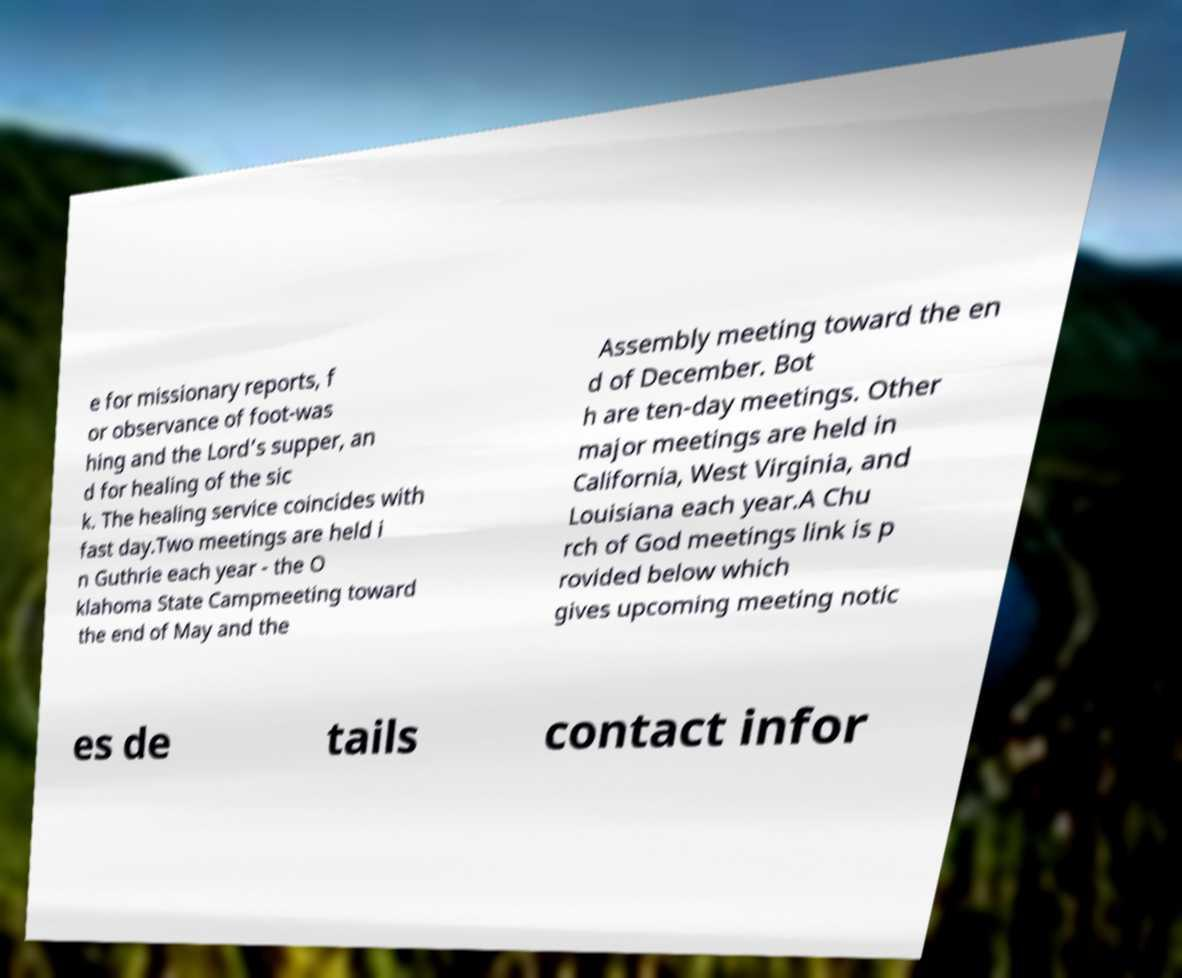For documentation purposes, I need the text within this image transcribed. Could you provide that? e for missionary reports, f or observance of foot-was hing and the Lord’s supper, an d for healing of the sic k. The healing service coincides with fast day.Two meetings are held i n Guthrie each year - the O klahoma State Campmeeting toward the end of May and the Assembly meeting toward the en d of December. Bot h are ten-day meetings. Other major meetings are held in California, West Virginia, and Louisiana each year.A Chu rch of God meetings link is p rovided below which gives upcoming meeting notic es de tails contact infor 